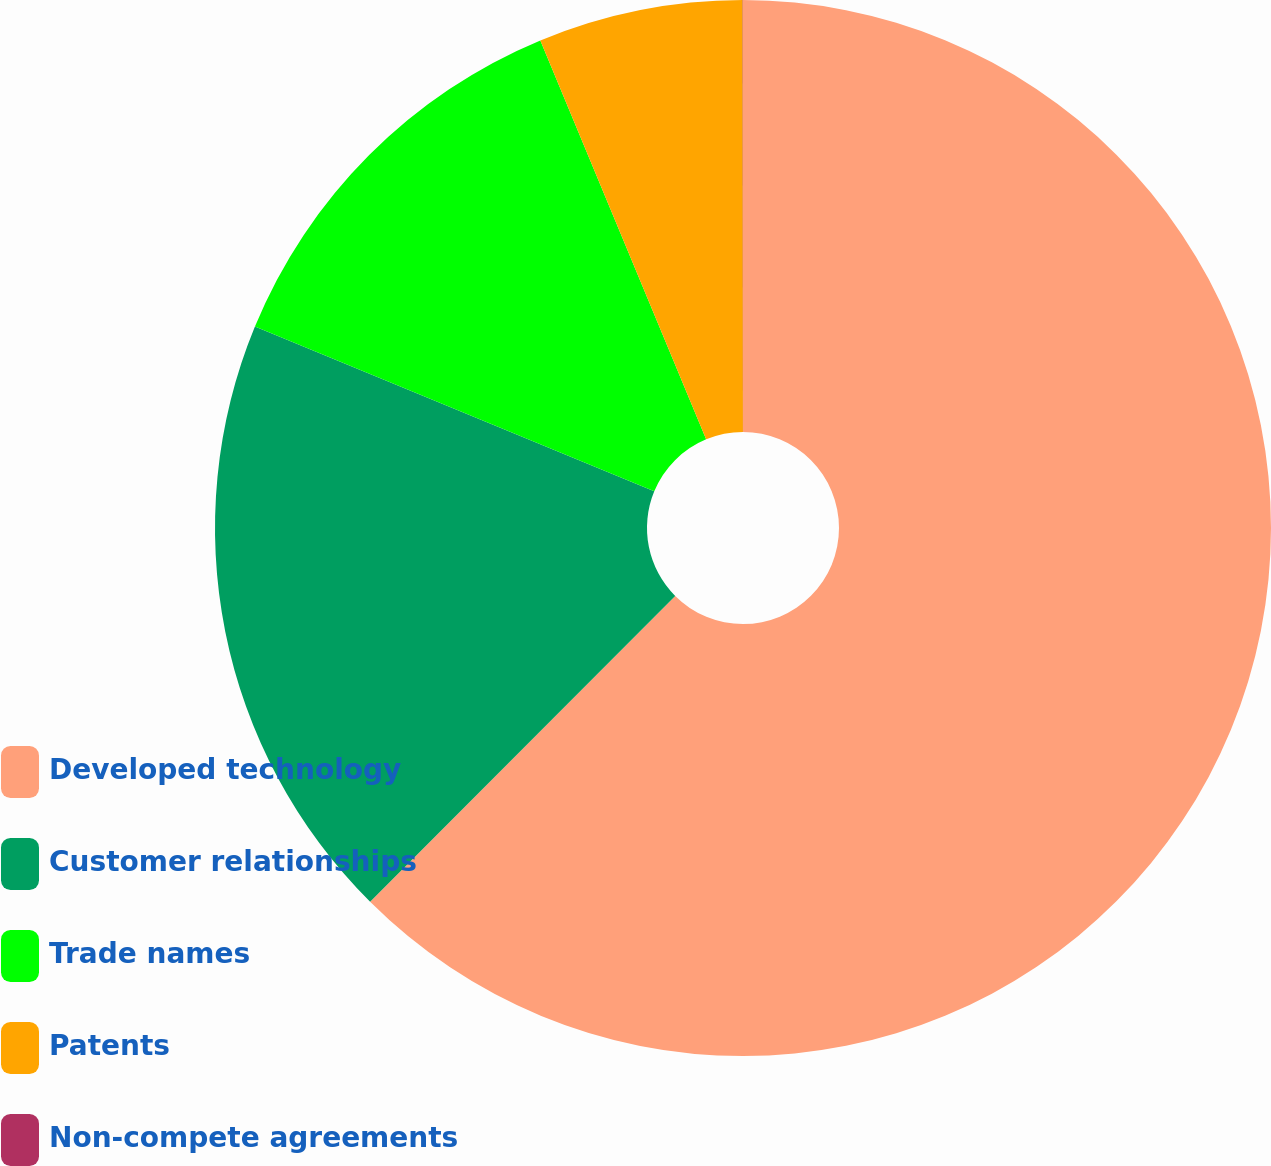Convert chart to OTSL. <chart><loc_0><loc_0><loc_500><loc_500><pie_chart><fcel>Developed technology<fcel>Customer relationships<fcel>Trade names<fcel>Patents<fcel>Non-compete agreements<nl><fcel>62.48%<fcel>18.75%<fcel>12.5%<fcel>6.26%<fcel>0.01%<nl></chart> 